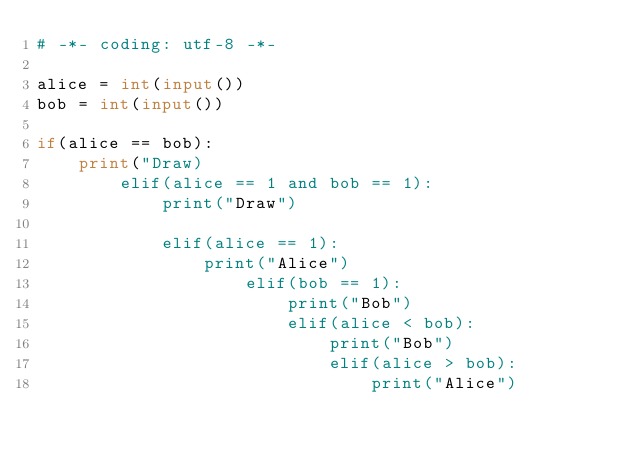<code> <loc_0><loc_0><loc_500><loc_500><_Python_># -*- coding: utf-8 -*-

alice = int(input())
bob = int(input())

if(alice == bob):
    print("Draw)
        elif(alice == 1 and bob == 1):
            print("Draw")
    
            elif(alice == 1):
                print("Alice")
                    elif(bob == 1):
                        print("Bob")
                        elif(alice < bob):
                            print("Bob")
                            elif(alice > bob):
                                print("Alice")
</code> 